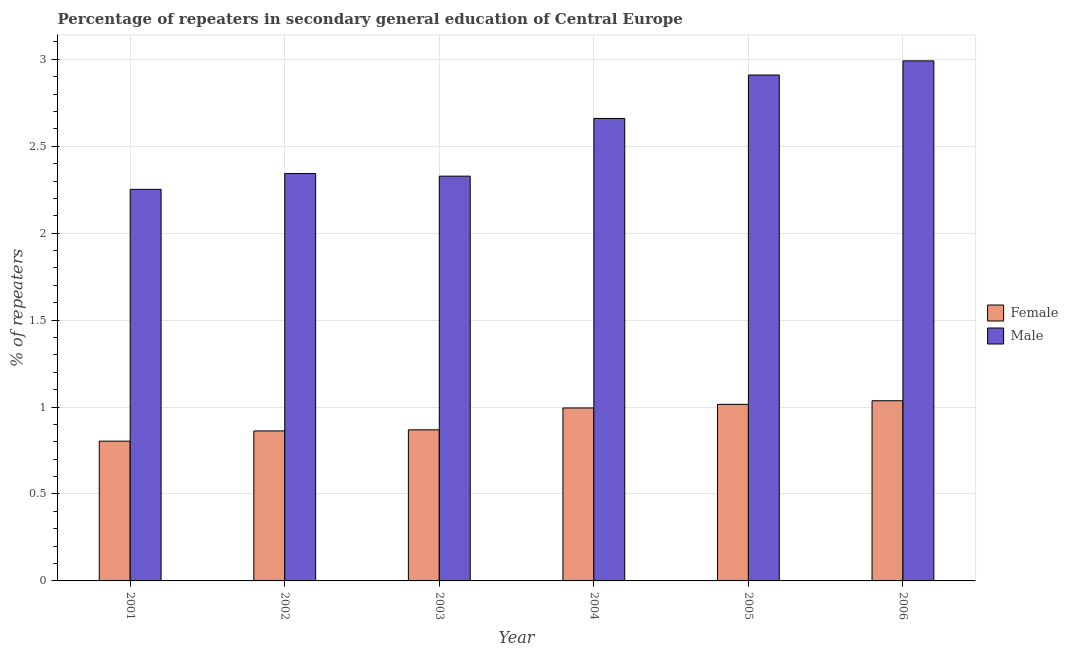How many bars are there on the 3rd tick from the left?
Your answer should be very brief. 2. How many bars are there on the 1st tick from the right?
Keep it short and to the point. 2. In how many cases, is the number of bars for a given year not equal to the number of legend labels?
Your response must be concise. 0. What is the percentage of female repeaters in 2002?
Offer a very short reply. 0.86. Across all years, what is the maximum percentage of female repeaters?
Your answer should be very brief. 1.04. Across all years, what is the minimum percentage of male repeaters?
Offer a terse response. 2.25. What is the total percentage of female repeaters in the graph?
Keep it short and to the point. 5.58. What is the difference between the percentage of male repeaters in 2001 and that in 2006?
Make the answer very short. -0.74. What is the difference between the percentage of male repeaters in 2005 and the percentage of female repeaters in 2004?
Provide a succinct answer. 0.25. What is the average percentage of male repeaters per year?
Offer a very short reply. 2.58. In how many years, is the percentage of female repeaters greater than 1.5 %?
Ensure brevity in your answer.  0. What is the ratio of the percentage of male repeaters in 2004 to that in 2006?
Your answer should be compact. 0.89. Is the percentage of male repeaters in 2002 less than that in 2005?
Your answer should be compact. Yes. Is the difference between the percentage of female repeaters in 2001 and 2002 greater than the difference between the percentage of male repeaters in 2001 and 2002?
Offer a terse response. No. What is the difference between the highest and the second highest percentage of male repeaters?
Provide a short and direct response. 0.08. What is the difference between the highest and the lowest percentage of male repeaters?
Your answer should be compact. 0.74. In how many years, is the percentage of male repeaters greater than the average percentage of male repeaters taken over all years?
Your response must be concise. 3. Is the sum of the percentage of female repeaters in 2002 and 2003 greater than the maximum percentage of male repeaters across all years?
Offer a terse response. Yes. How many years are there in the graph?
Keep it short and to the point. 6. Are the values on the major ticks of Y-axis written in scientific E-notation?
Your answer should be very brief. No. Does the graph contain any zero values?
Provide a succinct answer. No. What is the title of the graph?
Your answer should be very brief. Percentage of repeaters in secondary general education of Central Europe. Does "Methane emissions" appear as one of the legend labels in the graph?
Ensure brevity in your answer.  No. What is the label or title of the Y-axis?
Keep it short and to the point. % of repeaters. What is the % of repeaters in Female in 2001?
Your response must be concise. 0.8. What is the % of repeaters of Male in 2001?
Provide a short and direct response. 2.25. What is the % of repeaters of Female in 2002?
Your response must be concise. 0.86. What is the % of repeaters of Male in 2002?
Ensure brevity in your answer.  2.34. What is the % of repeaters in Female in 2003?
Provide a short and direct response. 0.87. What is the % of repeaters in Male in 2003?
Give a very brief answer. 2.33. What is the % of repeaters in Female in 2004?
Offer a terse response. 0.99. What is the % of repeaters in Male in 2004?
Keep it short and to the point. 2.66. What is the % of repeaters in Female in 2005?
Your answer should be compact. 1.02. What is the % of repeaters in Male in 2005?
Give a very brief answer. 2.91. What is the % of repeaters of Female in 2006?
Your response must be concise. 1.04. What is the % of repeaters in Male in 2006?
Give a very brief answer. 2.99. Across all years, what is the maximum % of repeaters in Female?
Your answer should be very brief. 1.04. Across all years, what is the maximum % of repeaters in Male?
Offer a very short reply. 2.99. Across all years, what is the minimum % of repeaters in Female?
Ensure brevity in your answer.  0.8. Across all years, what is the minimum % of repeaters of Male?
Your response must be concise. 2.25. What is the total % of repeaters of Female in the graph?
Make the answer very short. 5.58. What is the total % of repeaters in Male in the graph?
Your response must be concise. 15.48. What is the difference between the % of repeaters of Female in 2001 and that in 2002?
Offer a very short reply. -0.06. What is the difference between the % of repeaters in Male in 2001 and that in 2002?
Make the answer very short. -0.09. What is the difference between the % of repeaters in Female in 2001 and that in 2003?
Your answer should be very brief. -0.07. What is the difference between the % of repeaters of Male in 2001 and that in 2003?
Ensure brevity in your answer.  -0.08. What is the difference between the % of repeaters in Female in 2001 and that in 2004?
Your response must be concise. -0.19. What is the difference between the % of repeaters in Male in 2001 and that in 2004?
Provide a short and direct response. -0.41. What is the difference between the % of repeaters in Female in 2001 and that in 2005?
Provide a short and direct response. -0.21. What is the difference between the % of repeaters in Male in 2001 and that in 2005?
Offer a very short reply. -0.66. What is the difference between the % of repeaters of Female in 2001 and that in 2006?
Your response must be concise. -0.23. What is the difference between the % of repeaters of Male in 2001 and that in 2006?
Keep it short and to the point. -0.74. What is the difference between the % of repeaters in Female in 2002 and that in 2003?
Give a very brief answer. -0.01. What is the difference between the % of repeaters of Male in 2002 and that in 2003?
Your response must be concise. 0.01. What is the difference between the % of repeaters of Female in 2002 and that in 2004?
Ensure brevity in your answer.  -0.13. What is the difference between the % of repeaters of Male in 2002 and that in 2004?
Your response must be concise. -0.32. What is the difference between the % of repeaters in Female in 2002 and that in 2005?
Your answer should be compact. -0.15. What is the difference between the % of repeaters of Male in 2002 and that in 2005?
Keep it short and to the point. -0.57. What is the difference between the % of repeaters in Female in 2002 and that in 2006?
Give a very brief answer. -0.17. What is the difference between the % of repeaters of Male in 2002 and that in 2006?
Your answer should be very brief. -0.65. What is the difference between the % of repeaters in Female in 2003 and that in 2004?
Ensure brevity in your answer.  -0.13. What is the difference between the % of repeaters in Male in 2003 and that in 2004?
Keep it short and to the point. -0.33. What is the difference between the % of repeaters of Female in 2003 and that in 2005?
Provide a short and direct response. -0.15. What is the difference between the % of repeaters of Male in 2003 and that in 2005?
Provide a short and direct response. -0.58. What is the difference between the % of repeaters of Female in 2003 and that in 2006?
Your response must be concise. -0.17. What is the difference between the % of repeaters in Male in 2003 and that in 2006?
Provide a short and direct response. -0.66. What is the difference between the % of repeaters in Female in 2004 and that in 2005?
Keep it short and to the point. -0.02. What is the difference between the % of repeaters in Male in 2004 and that in 2005?
Make the answer very short. -0.25. What is the difference between the % of repeaters in Female in 2004 and that in 2006?
Provide a succinct answer. -0.04. What is the difference between the % of repeaters of Male in 2004 and that in 2006?
Your answer should be compact. -0.33. What is the difference between the % of repeaters in Female in 2005 and that in 2006?
Keep it short and to the point. -0.02. What is the difference between the % of repeaters of Male in 2005 and that in 2006?
Keep it short and to the point. -0.08. What is the difference between the % of repeaters in Female in 2001 and the % of repeaters in Male in 2002?
Ensure brevity in your answer.  -1.54. What is the difference between the % of repeaters in Female in 2001 and the % of repeaters in Male in 2003?
Keep it short and to the point. -1.52. What is the difference between the % of repeaters in Female in 2001 and the % of repeaters in Male in 2004?
Provide a short and direct response. -1.86. What is the difference between the % of repeaters of Female in 2001 and the % of repeaters of Male in 2005?
Ensure brevity in your answer.  -2.11. What is the difference between the % of repeaters of Female in 2001 and the % of repeaters of Male in 2006?
Keep it short and to the point. -2.19. What is the difference between the % of repeaters of Female in 2002 and the % of repeaters of Male in 2003?
Your response must be concise. -1.47. What is the difference between the % of repeaters in Female in 2002 and the % of repeaters in Male in 2004?
Offer a very short reply. -1.8. What is the difference between the % of repeaters of Female in 2002 and the % of repeaters of Male in 2005?
Give a very brief answer. -2.05. What is the difference between the % of repeaters of Female in 2002 and the % of repeaters of Male in 2006?
Provide a short and direct response. -2.13. What is the difference between the % of repeaters in Female in 2003 and the % of repeaters in Male in 2004?
Provide a short and direct response. -1.79. What is the difference between the % of repeaters in Female in 2003 and the % of repeaters in Male in 2005?
Offer a very short reply. -2.04. What is the difference between the % of repeaters in Female in 2003 and the % of repeaters in Male in 2006?
Offer a terse response. -2.12. What is the difference between the % of repeaters in Female in 2004 and the % of repeaters in Male in 2005?
Give a very brief answer. -1.91. What is the difference between the % of repeaters in Female in 2004 and the % of repeaters in Male in 2006?
Your answer should be compact. -2. What is the difference between the % of repeaters in Female in 2005 and the % of repeaters in Male in 2006?
Ensure brevity in your answer.  -1.98. What is the average % of repeaters of Female per year?
Offer a very short reply. 0.93. What is the average % of repeaters in Male per year?
Ensure brevity in your answer.  2.58. In the year 2001, what is the difference between the % of repeaters in Female and % of repeaters in Male?
Provide a succinct answer. -1.45. In the year 2002, what is the difference between the % of repeaters in Female and % of repeaters in Male?
Keep it short and to the point. -1.48. In the year 2003, what is the difference between the % of repeaters in Female and % of repeaters in Male?
Ensure brevity in your answer.  -1.46. In the year 2004, what is the difference between the % of repeaters of Female and % of repeaters of Male?
Offer a very short reply. -1.67. In the year 2005, what is the difference between the % of repeaters of Female and % of repeaters of Male?
Offer a terse response. -1.89. In the year 2006, what is the difference between the % of repeaters of Female and % of repeaters of Male?
Provide a short and direct response. -1.95. What is the ratio of the % of repeaters in Female in 2001 to that in 2002?
Keep it short and to the point. 0.93. What is the ratio of the % of repeaters in Male in 2001 to that in 2002?
Your answer should be very brief. 0.96. What is the ratio of the % of repeaters of Female in 2001 to that in 2003?
Ensure brevity in your answer.  0.93. What is the ratio of the % of repeaters of Male in 2001 to that in 2003?
Ensure brevity in your answer.  0.97. What is the ratio of the % of repeaters in Female in 2001 to that in 2004?
Offer a terse response. 0.81. What is the ratio of the % of repeaters in Male in 2001 to that in 2004?
Make the answer very short. 0.85. What is the ratio of the % of repeaters in Female in 2001 to that in 2005?
Your answer should be very brief. 0.79. What is the ratio of the % of repeaters of Male in 2001 to that in 2005?
Provide a succinct answer. 0.77. What is the ratio of the % of repeaters in Female in 2001 to that in 2006?
Offer a terse response. 0.78. What is the ratio of the % of repeaters of Male in 2001 to that in 2006?
Provide a short and direct response. 0.75. What is the ratio of the % of repeaters of Female in 2002 to that in 2003?
Offer a very short reply. 0.99. What is the ratio of the % of repeaters in Male in 2002 to that in 2003?
Ensure brevity in your answer.  1.01. What is the ratio of the % of repeaters of Female in 2002 to that in 2004?
Keep it short and to the point. 0.87. What is the ratio of the % of repeaters of Male in 2002 to that in 2004?
Provide a short and direct response. 0.88. What is the ratio of the % of repeaters of Female in 2002 to that in 2005?
Make the answer very short. 0.85. What is the ratio of the % of repeaters of Male in 2002 to that in 2005?
Your answer should be compact. 0.81. What is the ratio of the % of repeaters of Female in 2002 to that in 2006?
Offer a terse response. 0.83. What is the ratio of the % of repeaters of Male in 2002 to that in 2006?
Provide a short and direct response. 0.78. What is the ratio of the % of repeaters in Female in 2003 to that in 2004?
Ensure brevity in your answer.  0.87. What is the ratio of the % of repeaters of Male in 2003 to that in 2004?
Offer a terse response. 0.88. What is the ratio of the % of repeaters in Female in 2003 to that in 2005?
Provide a short and direct response. 0.86. What is the ratio of the % of repeaters of Male in 2003 to that in 2005?
Ensure brevity in your answer.  0.8. What is the ratio of the % of repeaters of Female in 2003 to that in 2006?
Give a very brief answer. 0.84. What is the ratio of the % of repeaters in Male in 2003 to that in 2006?
Give a very brief answer. 0.78. What is the ratio of the % of repeaters in Female in 2004 to that in 2005?
Your answer should be compact. 0.98. What is the ratio of the % of repeaters in Male in 2004 to that in 2005?
Your response must be concise. 0.91. What is the ratio of the % of repeaters in Female in 2004 to that in 2006?
Make the answer very short. 0.96. What is the ratio of the % of repeaters in Male in 2004 to that in 2006?
Your answer should be very brief. 0.89. What is the ratio of the % of repeaters in Female in 2005 to that in 2006?
Provide a short and direct response. 0.98. What is the ratio of the % of repeaters of Male in 2005 to that in 2006?
Your response must be concise. 0.97. What is the difference between the highest and the second highest % of repeaters in Female?
Provide a short and direct response. 0.02. What is the difference between the highest and the second highest % of repeaters of Male?
Your response must be concise. 0.08. What is the difference between the highest and the lowest % of repeaters in Female?
Provide a succinct answer. 0.23. What is the difference between the highest and the lowest % of repeaters in Male?
Offer a terse response. 0.74. 